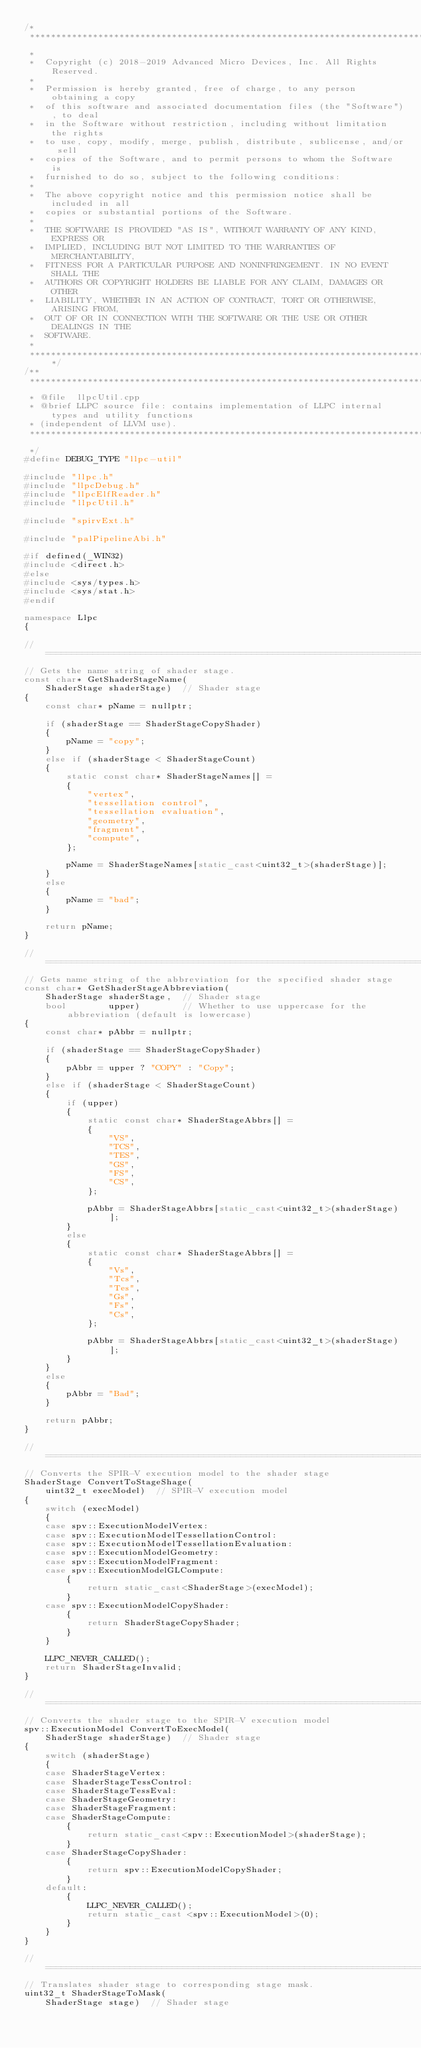Convert code to text. <code><loc_0><loc_0><loc_500><loc_500><_C++_>/*
 ***********************************************************************************************************************
 *
 *  Copyright (c) 2018-2019 Advanced Micro Devices, Inc. All Rights Reserved.
 *
 *  Permission is hereby granted, free of charge, to any person obtaining a copy
 *  of this software and associated documentation files (the "Software"), to deal
 *  in the Software without restriction, including without limitation the rights
 *  to use, copy, modify, merge, publish, distribute, sublicense, and/or sell
 *  copies of the Software, and to permit persons to whom the Software is
 *  furnished to do so, subject to the following conditions:
 *
 *  The above copyright notice and this permission notice shall be included in all
 *  copies or substantial portions of the Software.
 *
 *  THE SOFTWARE IS PROVIDED "AS IS", WITHOUT WARRANTY OF ANY KIND, EXPRESS OR
 *  IMPLIED, INCLUDING BUT NOT LIMITED TO THE WARRANTIES OF MERCHANTABILITY,
 *  FITNESS FOR A PARTICULAR PURPOSE AND NONINFRINGEMENT. IN NO EVENT SHALL THE
 *  AUTHORS OR COPYRIGHT HOLDERS BE LIABLE FOR ANY CLAIM, DAMAGES OR OTHER
 *  LIABILITY, WHETHER IN AN ACTION OF CONTRACT, TORT OR OTHERWISE, ARISING FROM,
 *  OUT OF OR IN CONNECTION WITH THE SOFTWARE OR THE USE OR OTHER DEALINGS IN THE
 *  SOFTWARE.
 *
 **********************************************************************************************************************/
/**
 ***********************************************************************************************************************
 * @file  llpcUtil.cpp
 * @brief LLPC source file: contains implementation of LLPC internal types and utility functions
 * (independent of LLVM use).
 ***********************************************************************************************************************
 */
#define DEBUG_TYPE "llpc-util"

#include "llpc.h"
#include "llpcDebug.h"
#include "llpcElfReader.h"
#include "llpcUtil.h"

#include "spirvExt.h"

#include "palPipelineAbi.h"

#if defined(_WIN32)
#include <direct.h>
#else
#include <sys/types.h>
#include <sys/stat.h>
#endif

namespace Llpc
{

// =====================================================================================================================
// Gets the name string of shader stage.
const char* GetShaderStageName(
    ShaderStage shaderStage)  // Shader stage
{
    const char* pName = nullptr;

    if (shaderStage == ShaderStageCopyShader)
    {
        pName = "copy";
    }
    else if (shaderStage < ShaderStageCount)
    {
        static const char* ShaderStageNames[] =
        {
            "vertex",
            "tessellation control",
            "tessellation evaluation",
            "geometry",
            "fragment",
            "compute",
        };

        pName = ShaderStageNames[static_cast<uint32_t>(shaderStage)];
    }
    else
    {
        pName = "bad";
    }

    return pName;
}

// =====================================================================================================================
// Gets name string of the abbreviation for the specified shader stage
const char* GetShaderStageAbbreviation(
    ShaderStage shaderStage,  // Shader stage
    bool        upper)        // Whether to use uppercase for the abbreviation (default is lowercase)
{
    const char* pAbbr = nullptr;

    if (shaderStage == ShaderStageCopyShader)
    {
        pAbbr = upper ? "COPY" : "Copy";
    }
    else if (shaderStage < ShaderStageCount)
    {
        if (upper)
        {
            static const char* ShaderStageAbbrs[] =
            {
                "VS",
                "TCS",
                "TES",
                "GS",
                "FS",
                "CS",
            };

            pAbbr = ShaderStageAbbrs[static_cast<uint32_t>(shaderStage)];
        }
        else
        {
            static const char* ShaderStageAbbrs[] =
            {
                "Vs",
                "Tcs",
                "Tes",
                "Gs",
                "Fs",
                "Cs",
            };

            pAbbr = ShaderStageAbbrs[static_cast<uint32_t>(shaderStage)];
        }
    }
    else
    {
        pAbbr = "Bad";
    }

    return pAbbr;
}

// =====================================================================================================================
// Converts the SPIR-V execution model to the shader stage
ShaderStage ConvertToStageShage(
    uint32_t execModel)  // SPIR-V execution model
{
    switch (execModel)
    {
    case spv::ExecutionModelVertex:
    case spv::ExecutionModelTessellationControl:
    case spv::ExecutionModelTessellationEvaluation:
    case spv::ExecutionModelGeometry:
    case spv::ExecutionModelFragment:
    case spv::ExecutionModelGLCompute:
        {
            return static_cast<ShaderStage>(execModel);
        }
    case spv::ExecutionModelCopyShader:
        {
            return ShaderStageCopyShader;
        }
    }

    LLPC_NEVER_CALLED();
    return ShaderStageInvalid;
}

// =====================================================================================================================
// Converts the shader stage to the SPIR-V execution model
spv::ExecutionModel ConvertToExecModel(
    ShaderStage shaderStage)  // Shader stage
{
    switch (shaderStage)
    {
    case ShaderStageVertex:
    case ShaderStageTessControl:
    case ShaderStageTessEval:
    case ShaderStageGeometry:
    case ShaderStageFragment:
    case ShaderStageCompute:
        {
            return static_cast<spv::ExecutionModel>(shaderStage);
        }
    case ShaderStageCopyShader:
        {
            return spv::ExecutionModelCopyShader;
        }
    default:
        {
            LLPC_NEVER_CALLED();
            return static_cast <spv::ExecutionModel>(0);
        }
    }
}

// =====================================================================================================================
// Translates shader stage to corresponding stage mask.
uint32_t ShaderStageToMask(
    ShaderStage stage)  // Shader stage</code> 